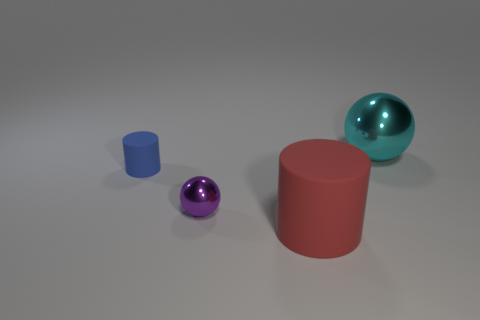Add 1 red metal blocks. How many objects exist? 5 Subtract 1 red cylinders. How many objects are left? 3 Subtract all gray balls. Subtract all blue cylinders. How many balls are left? 2 Subtract all large cyan metal things. Subtract all metal spheres. How many objects are left? 1 Add 2 large cyan metallic spheres. How many large cyan metallic spheres are left? 3 Add 4 tiny metallic spheres. How many tiny metallic spheres exist? 5 